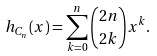<formula> <loc_0><loc_0><loc_500><loc_500>h _ { C _ { n } } ( x ) = \sum _ { k = 0 } ^ { n } \binom { 2 n } { 2 k } x ^ { k } .</formula> 